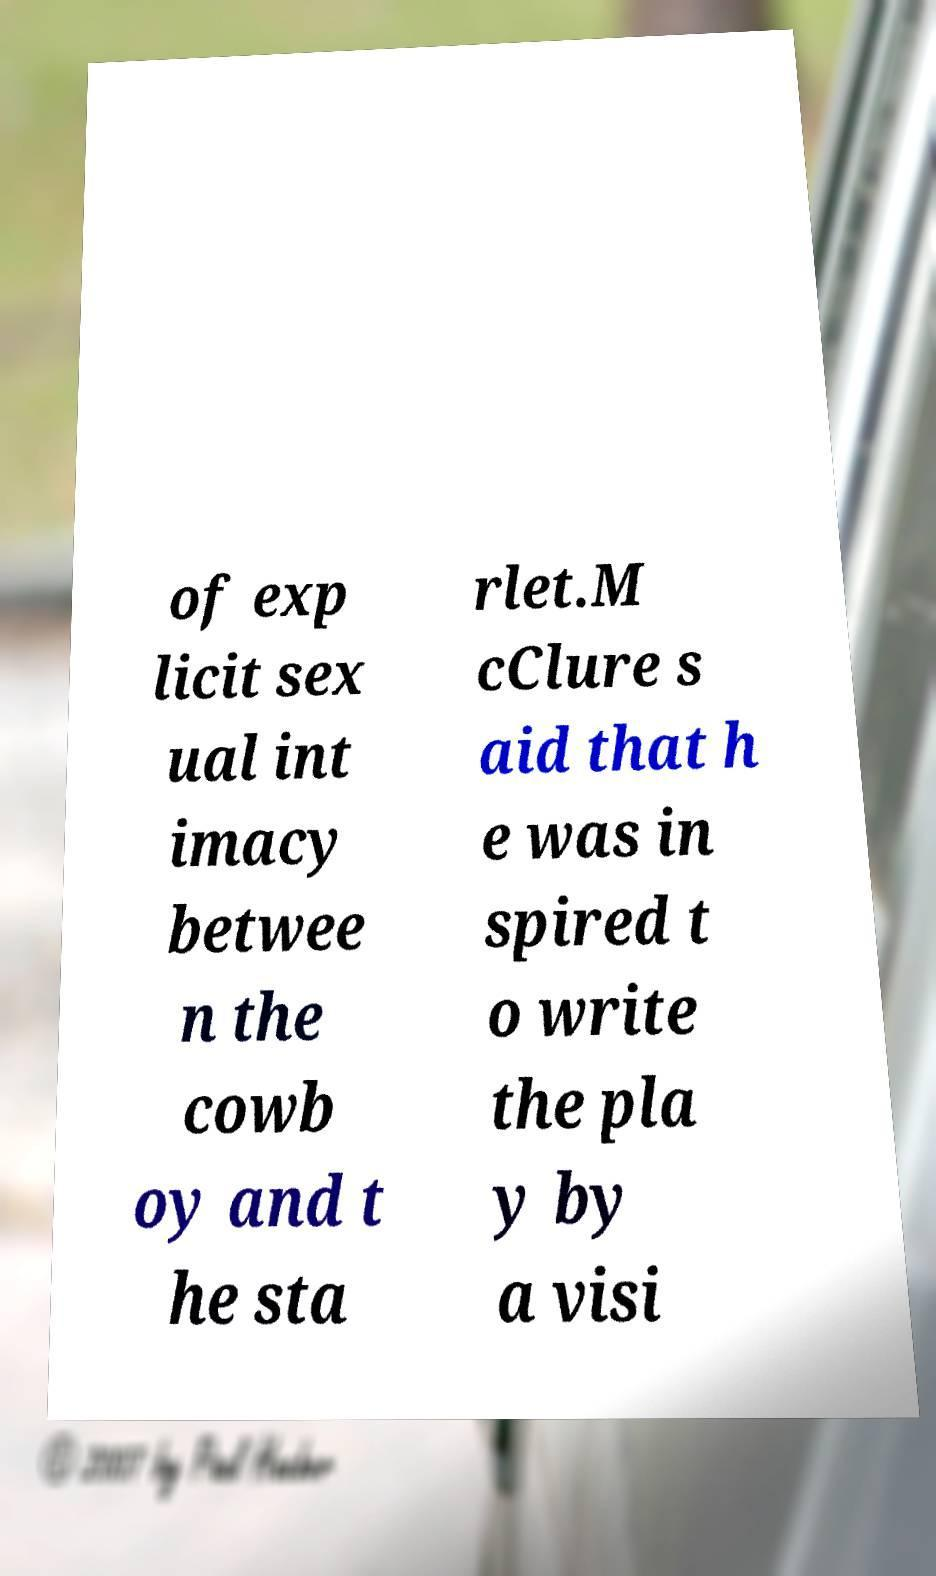What messages or text are displayed in this image? I need them in a readable, typed format. of exp licit sex ual int imacy betwee n the cowb oy and t he sta rlet.M cClure s aid that h e was in spired t o write the pla y by a visi 